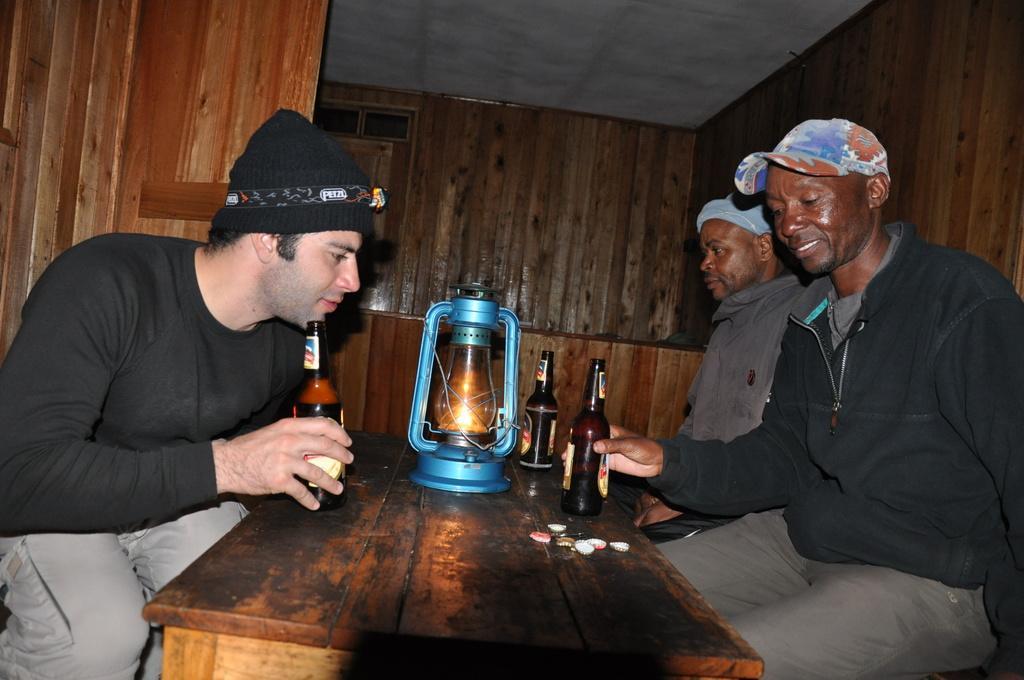In one or two sentences, can you explain what this image depicts? in this picture we can see three men sitting on chairs in front of a table and these two men hold bottles in their hands. Here we can see caps, lantern, bottles on the table. This is a ceiling. 